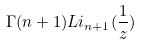Convert formula to latex. <formula><loc_0><loc_0><loc_500><loc_500>\Gamma ( n + 1 ) L i _ { n + 1 } ( \frac { 1 } { z } )</formula> 